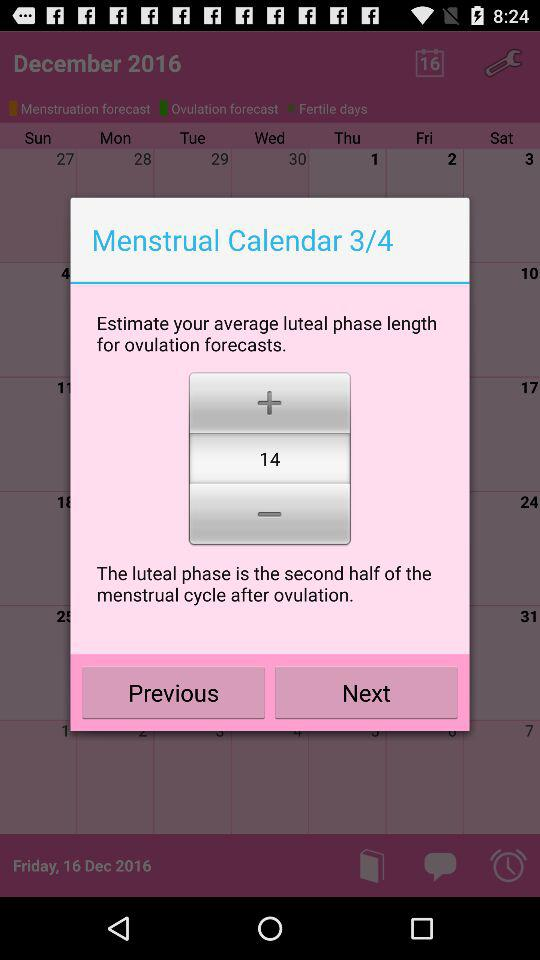What is the average number of days in the luteal phase?
Answer the question using a single word or phrase. 14 